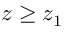<formula> <loc_0><loc_0><loc_500><loc_500>z \geq z _ { 1 }</formula> 